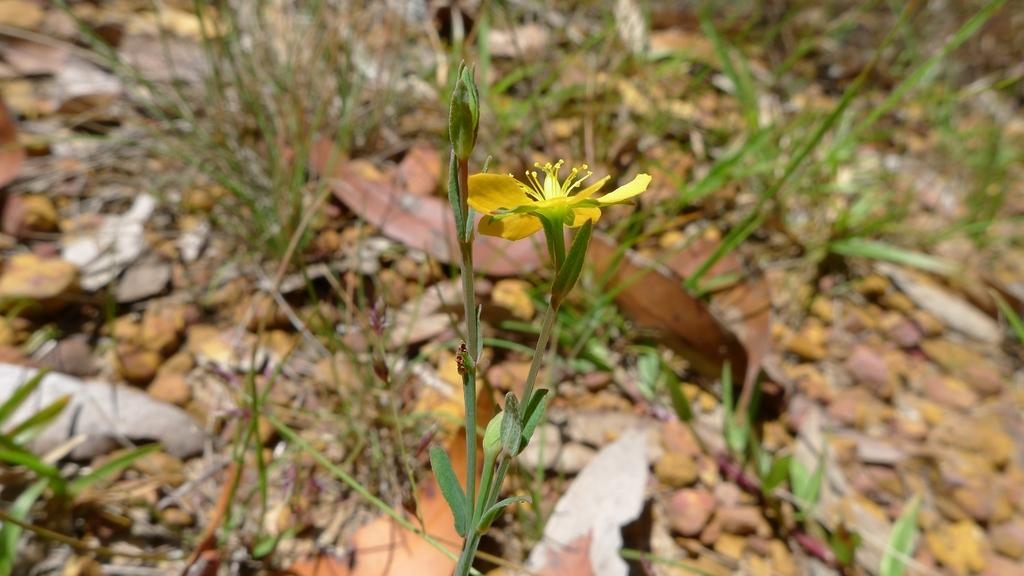What type of flower can be seen in the image? There is a yellow flower in the image. What else is present in the image besides the flower? There is a plant, grass, stones, and dry leaves visible in the image. Can you describe the background of the image? The background of the image has a blurred view. How many feet are visible in the image? There are no feet visible in the image. What type of quilt is covering the plant in the image? There is no quilt present in the image; it is a plant with a yellow flower and other elements. 